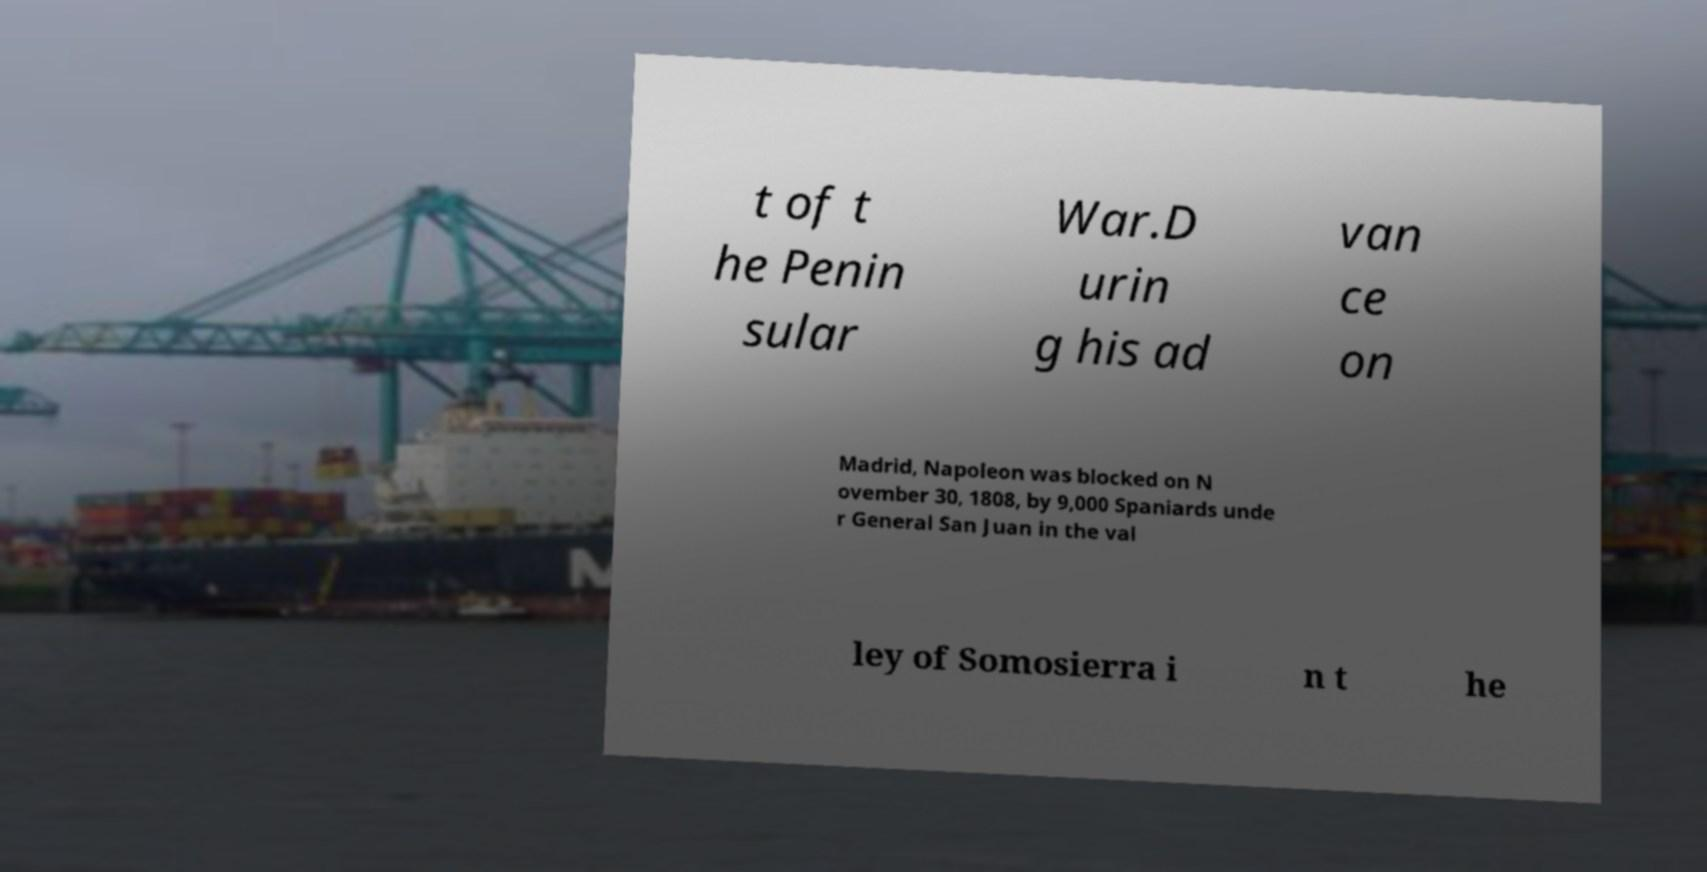Can you accurately transcribe the text from the provided image for me? t of t he Penin sular War.D urin g his ad van ce on Madrid, Napoleon was blocked on N ovember 30, 1808, by 9,000 Spaniards unde r General San Juan in the val ley of Somosierra i n t he 